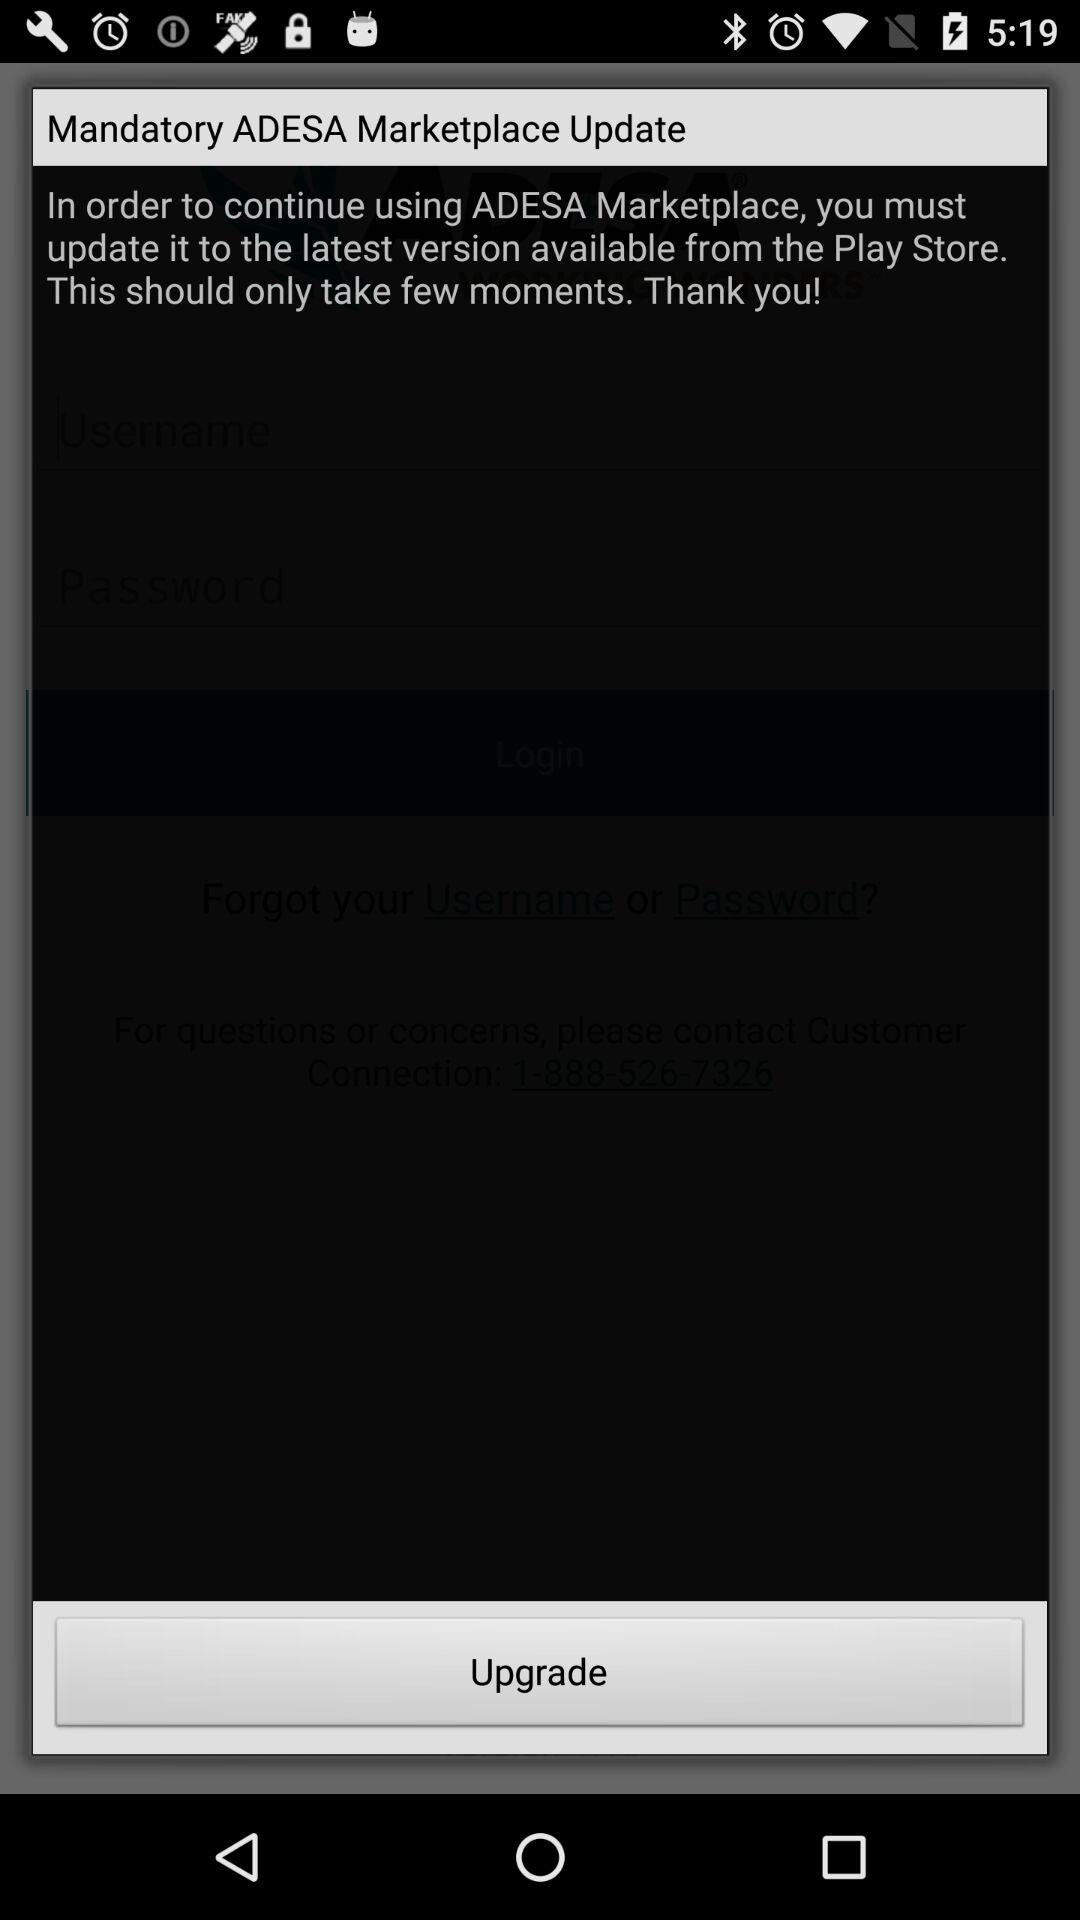What is the name of the application? The application name is "ADESA Marketplace". 